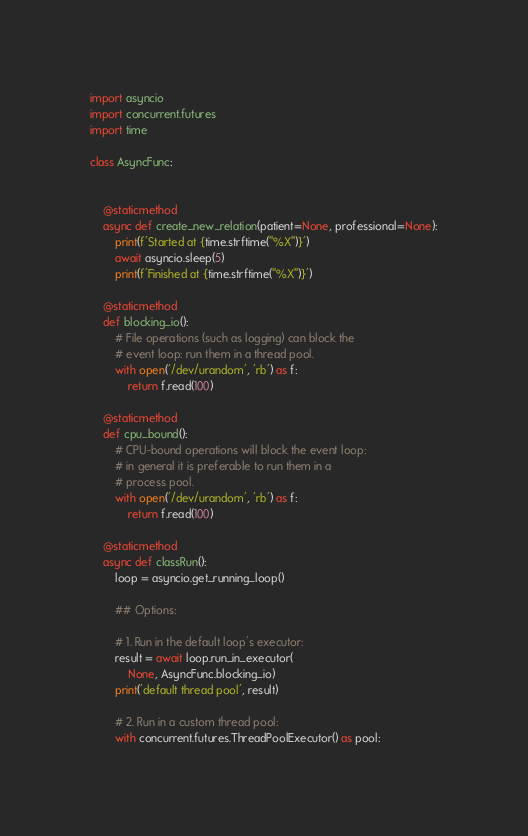Convert code to text. <code><loc_0><loc_0><loc_500><loc_500><_Python_>import asyncio
import concurrent.futures
import time

class AsyncFunc:
	

	@staticmethod
	async def create_new_relation(patient=None, professional=None):
		print(f'Started at {time.strftime("%X")}')
		await asyncio.sleep(5)
		print(f'Finished at {time.strftime("%X")}')
	
	@staticmethod
	def blocking_io():
		# File operations (such as logging) can block the
		# event loop: run them in a thread pool.
		with open('/dev/urandom', 'rb') as f:
			return f.read(100)
	
	@staticmethod
	def cpu_bound():
		# CPU-bound operations will block the event loop:
		# in general it is preferable to run them in a
		# process pool.
		with open('/dev/urandom', 'rb') as f:
			return f.read(100)
		
	@staticmethod
	async def classRun():
		loop = asyncio.get_running_loop()
		
		## Options:
		
		# 1. Run in the default loop's executor:
		result = await loop.run_in_executor(
			None, AsyncFunc.blocking_io)
		print('default thread pool', result)
		
		# 2. Run in a custom thread pool:
		with concurrent.futures.ThreadPoolExecutor() as pool:</code> 